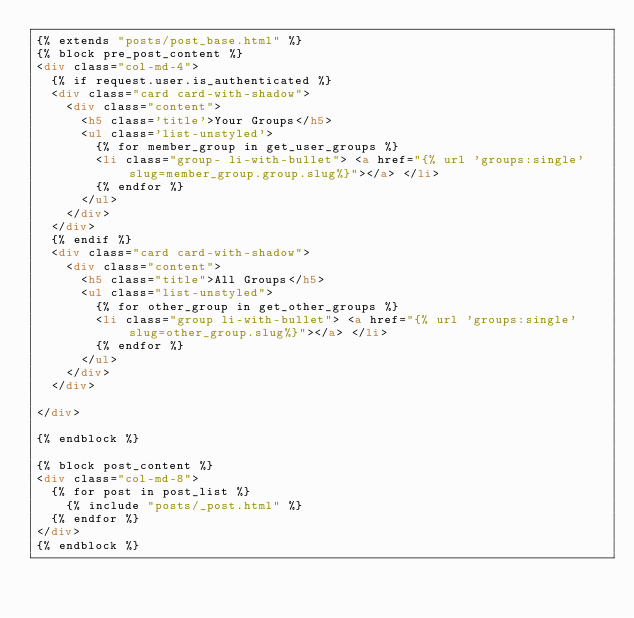<code> <loc_0><loc_0><loc_500><loc_500><_HTML_>{% extends "posts/post_base.html" %}
{% block pre_post_content %}
<div class="col-md-4">
  {% if request.user.is_authenticated %}
  <div class="card card-with-shadow">
    <div class="content">
      <h5 class='title'>Your Groups</h5>
      <ul class='list-unstyled'>
        {% for member_group in get_user_groups %}
        <li class="group- li-with-bullet"> <a href="{% url 'groups:single' slug=member_group.group.slug%}"></a> </li>
        {% endfor %}
      </ul>
    </div>
  </div>
  {% endif %}
  <div class="card card-with-shadow">
    <div class="content">
      <h5 class="title">All Groups</h5>
      <ul class="list-unstyled">
        {% for other_group in get_other_groups %}
        <li class="group li-with-bullet"> <a href="{% url 'groups:single' slug=other_group.slug%}"></a> </li>
        {% endfor %}
      </ul>
    </div>
  </div>

</div>

{% endblock %}

{% block post_content %}
<div class="col-md-8">
  {% for post in post_list %}
    {% include "posts/_post.html" %}
  {% endfor %}
</div>
{% endblock %}
</code> 